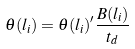<formula> <loc_0><loc_0><loc_500><loc_500>\theta ( l _ { i } ) = \theta ( l _ { i } ) ^ { \prime } \frac { B ( l _ { i } ) } { t _ { d } }</formula> 